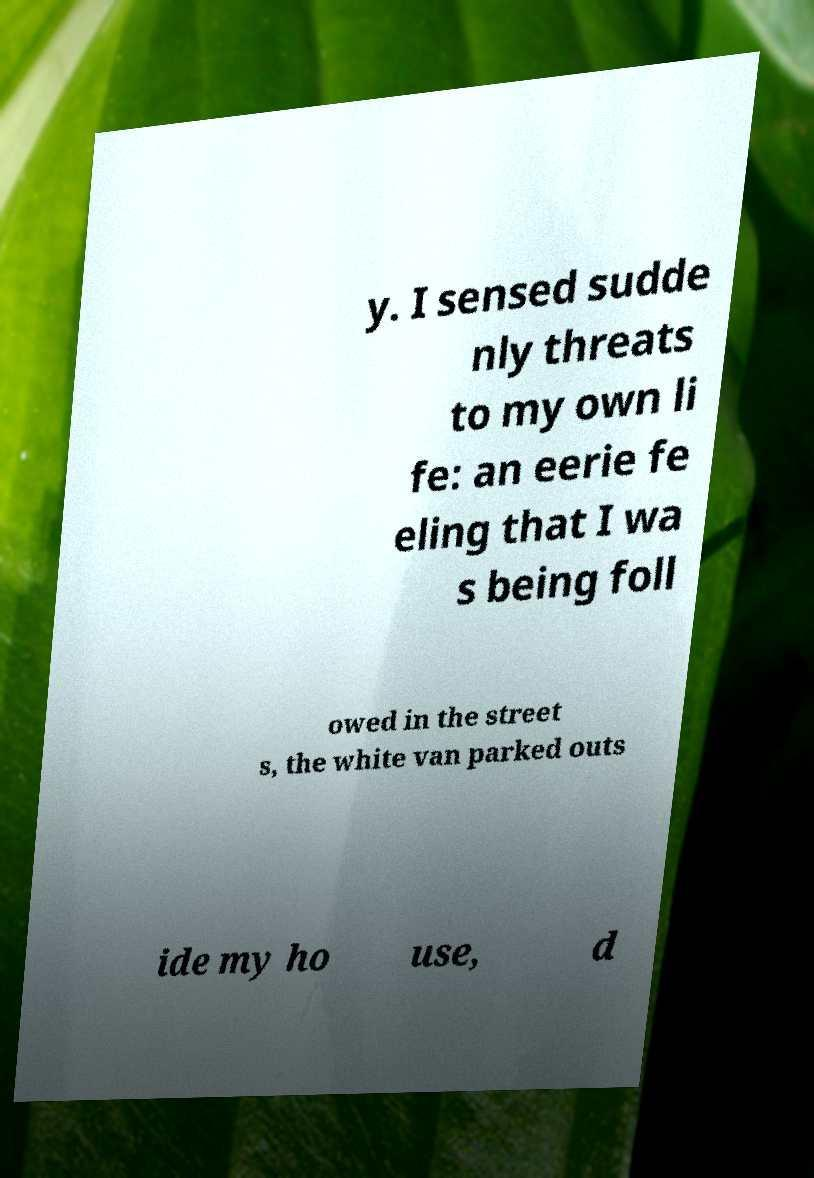Could you assist in decoding the text presented in this image and type it out clearly? y. I sensed sudde nly threats to my own li fe: an eerie fe eling that I wa s being foll owed in the street s, the white van parked outs ide my ho use, d 